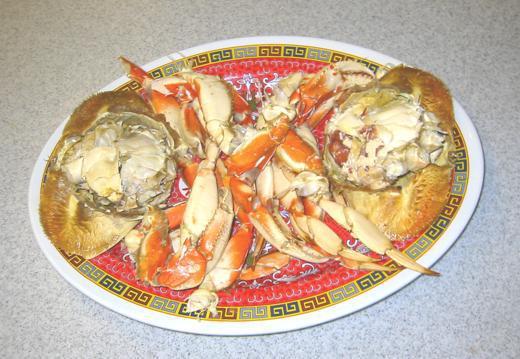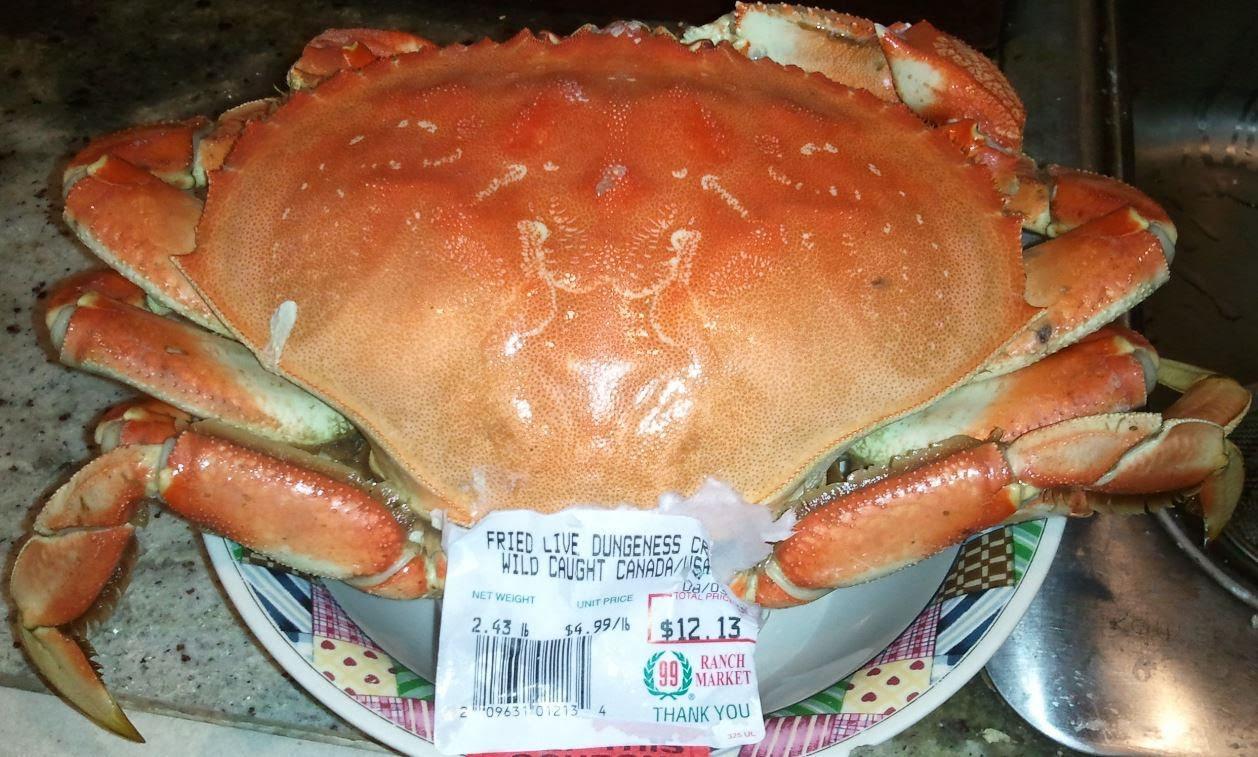The first image is the image on the left, the second image is the image on the right. Assess this claim about the two images: "All the crabs are piled on top of one another.". Correct or not? Answer yes or no. No. The first image is the image on the left, the second image is the image on the right. Considering the images on both sides, is "In the right image, a white rectangular label is overlapping a red-orange-shelled crab that is in some type of container." valid? Answer yes or no. Yes. 